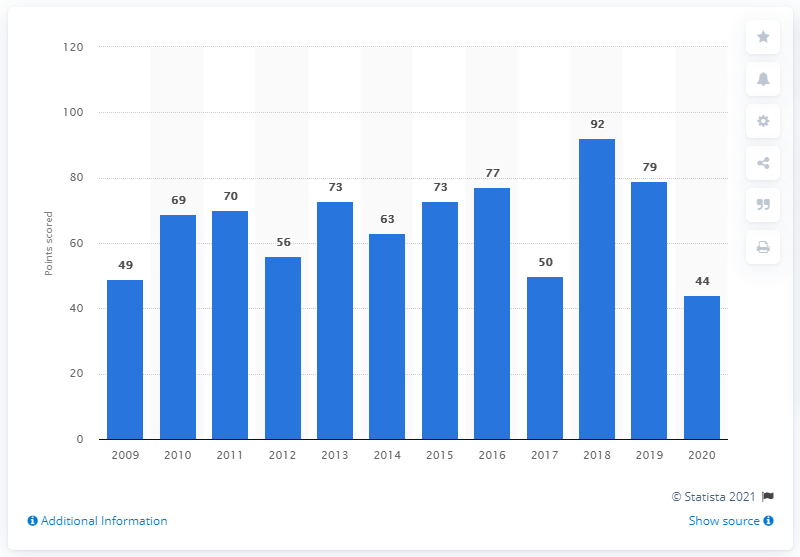Point out several critical features in this image. The Italian men's team scored its highest total points in 2018. 